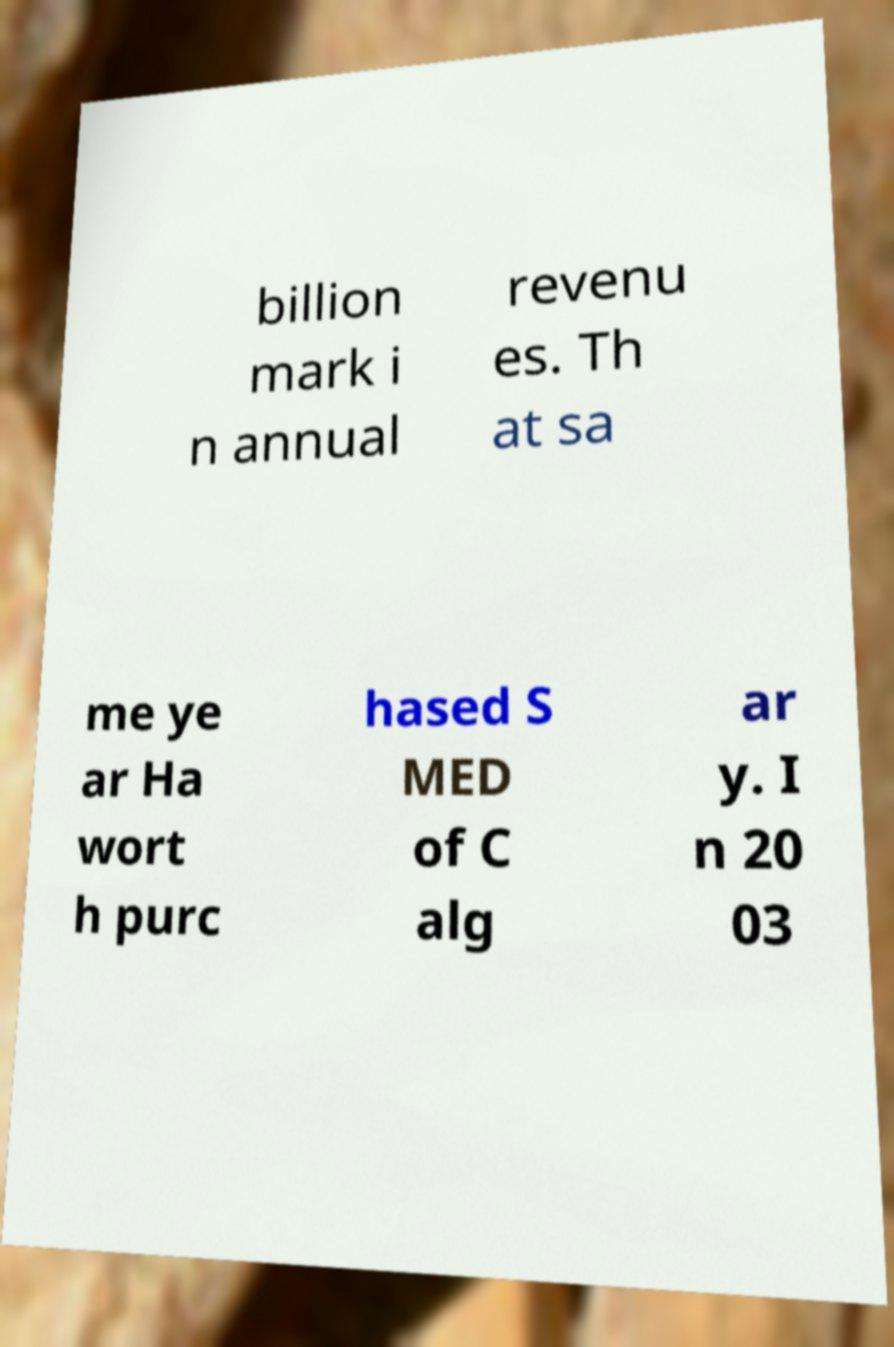Could you extract and type out the text from this image? billion mark i n annual revenu es. Th at sa me ye ar Ha wort h purc hased S MED of C alg ar y. I n 20 03 